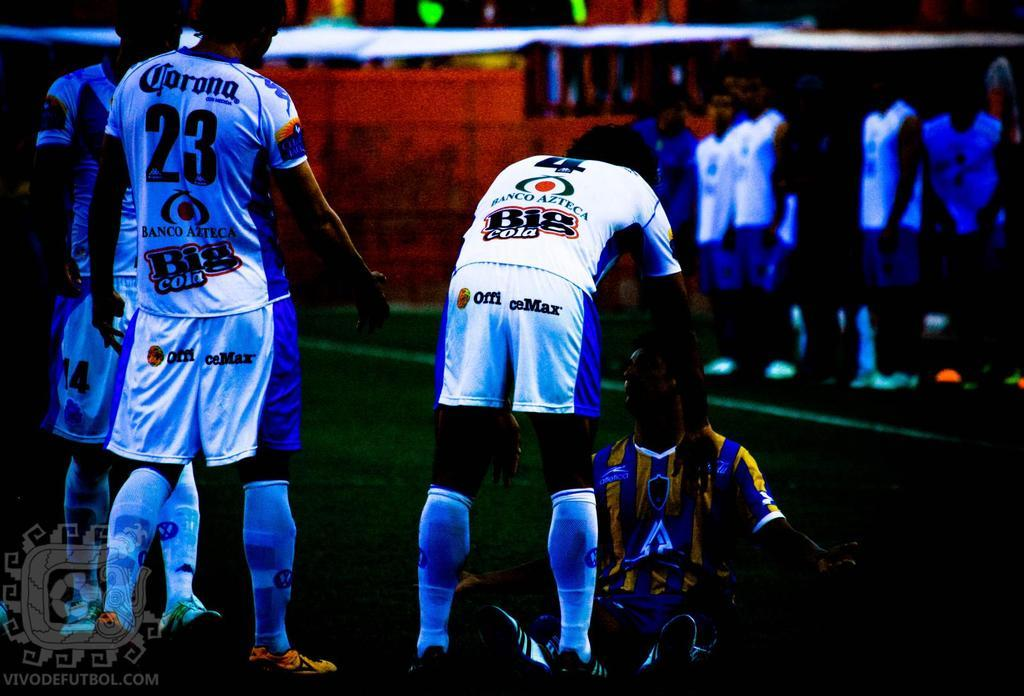<image>
Write a terse but informative summary of the picture. a soccer player has endorsements on his uniform from office max 